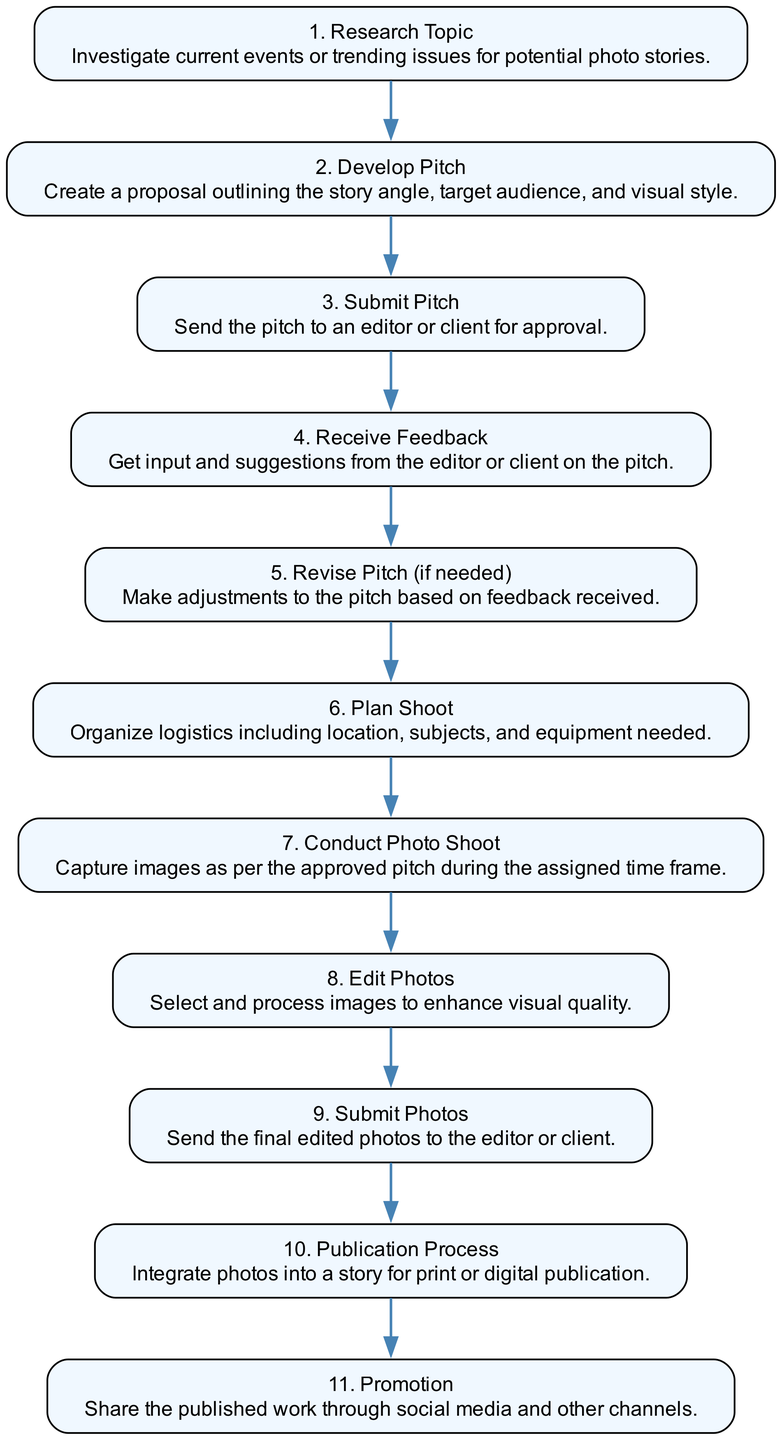What is the first step in the photo assignment workflow? The first step listed in the diagram is "Research Topic," which involves investigating current events or trending issues for potential photo stories.
Answer: Research Topic How many total steps are there in the workflow? By counting the labeled steps in the diagram, there are eleven distinct elements representing steps in the workflow.
Answer: Eleven Which step follows "Receive Feedback"? According to the diagram's flow, "Revise Pitch (if needed)" directly follows "Receive Feedback," indicating that adjustments to the pitch are made after receiving input.
Answer: Revise Pitch (if needed) What describes the purpose of the "Submission Process"? The "Submission Process" involves sending the final edited photos to either the editor or client, effectively moving the workflow toward publication.
Answer: Send the final edited photos What is the last step in the photo assignment workflow? The final step identified in the sequence diagram is "Promotion," which entails sharing the published work through social media and other channels.
Answer: Promotion Which steps include revisions or feedback? The steps that involve revisions or feedback are "Receive Feedback" and "Revise Pitch (if needed)," indicating the iterative process of improving the proposal based on discussion with an editor or client.
Answer: Receive Feedback, Revise Pitch (if needed) What is the relationship between "Conduct Photo Shoot" and "Edit Photos"? The relationship between these two steps is sequential, with "Conduct Photo Shoot" occurring first and providing the raw images needed for the subsequent step, "Edit Photos."
Answer: Sequential relationship Name all steps that occur after the "Plan Shoot" step. After "Plan Shoot," the sequence proceeds to "Conduct Photo Shoot," followed by "Edit Photos," "Submit Photos," and then the "Publication Process," leading toward the final promotion.
Answer: Conduct Photo Shoot, Edit Photos, Submit Photos, Publication Process, Promotion 